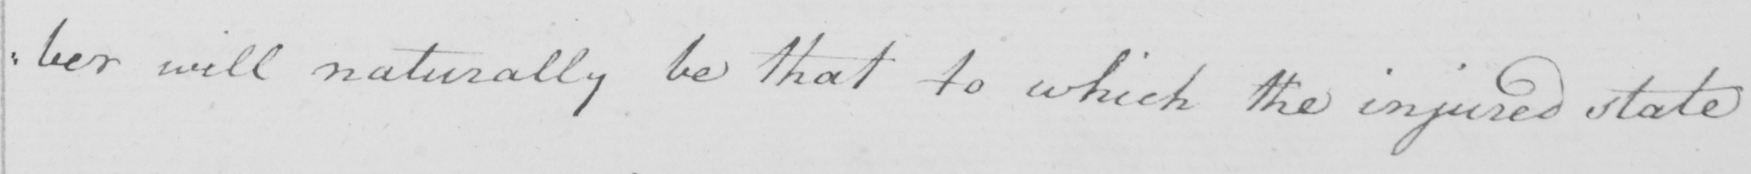Please transcribe the handwritten text in this image. :ber will naturally be that to which the injured state 